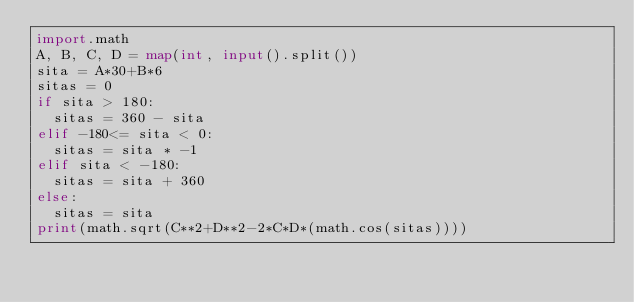Convert code to text. <code><loc_0><loc_0><loc_500><loc_500><_Python_>import.math
A, B, C, D = map(int, input().split())
sita = A*30+B*6
sitas = 0
if sita > 180:
  sitas = 360 - sita
elif -180<= sita < 0:
  sitas = sita * -1
elif sita < -180:
  sitas = sita + 360
else:
  sitas = sita
print(math.sqrt(C**2+D**2-2*C*D*(math.cos(sitas))))</code> 